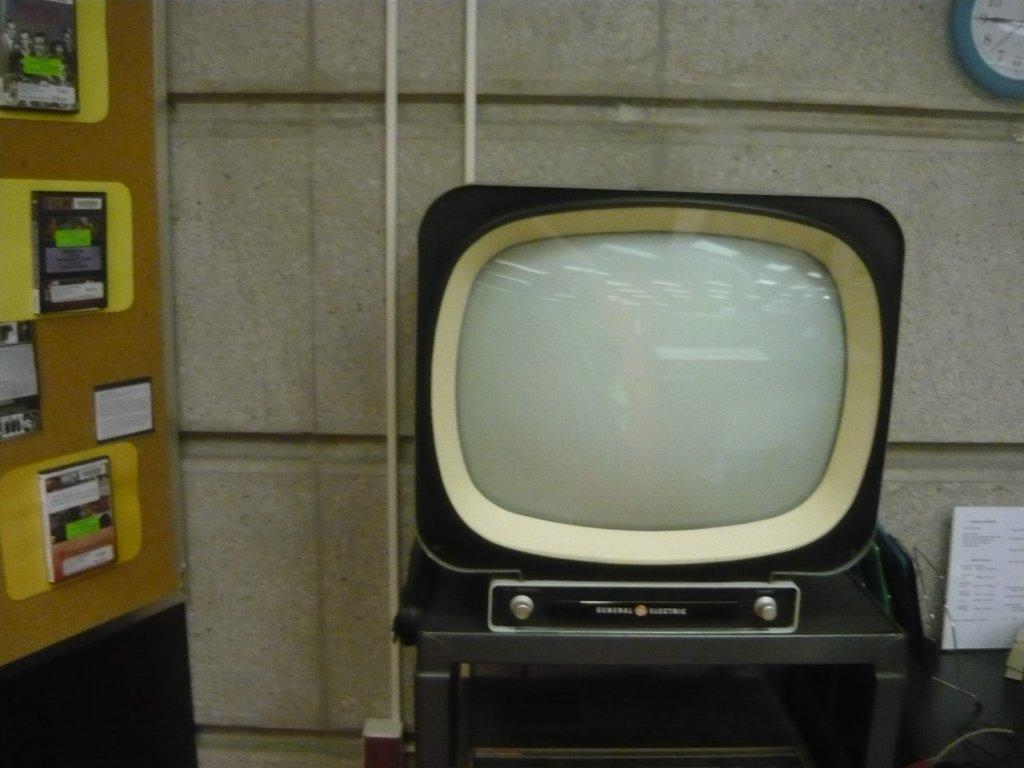What is the main object on the table in the image? There is a television on a table in the image. What can be seen on the wall in the image? There is a clock and a board on the wall in the image. What type of items are on a surface in the image? There are books on a surface in the image. How much profit did the daughter make from selling the books in the image? There is no daughter or mention of selling books in the image. 